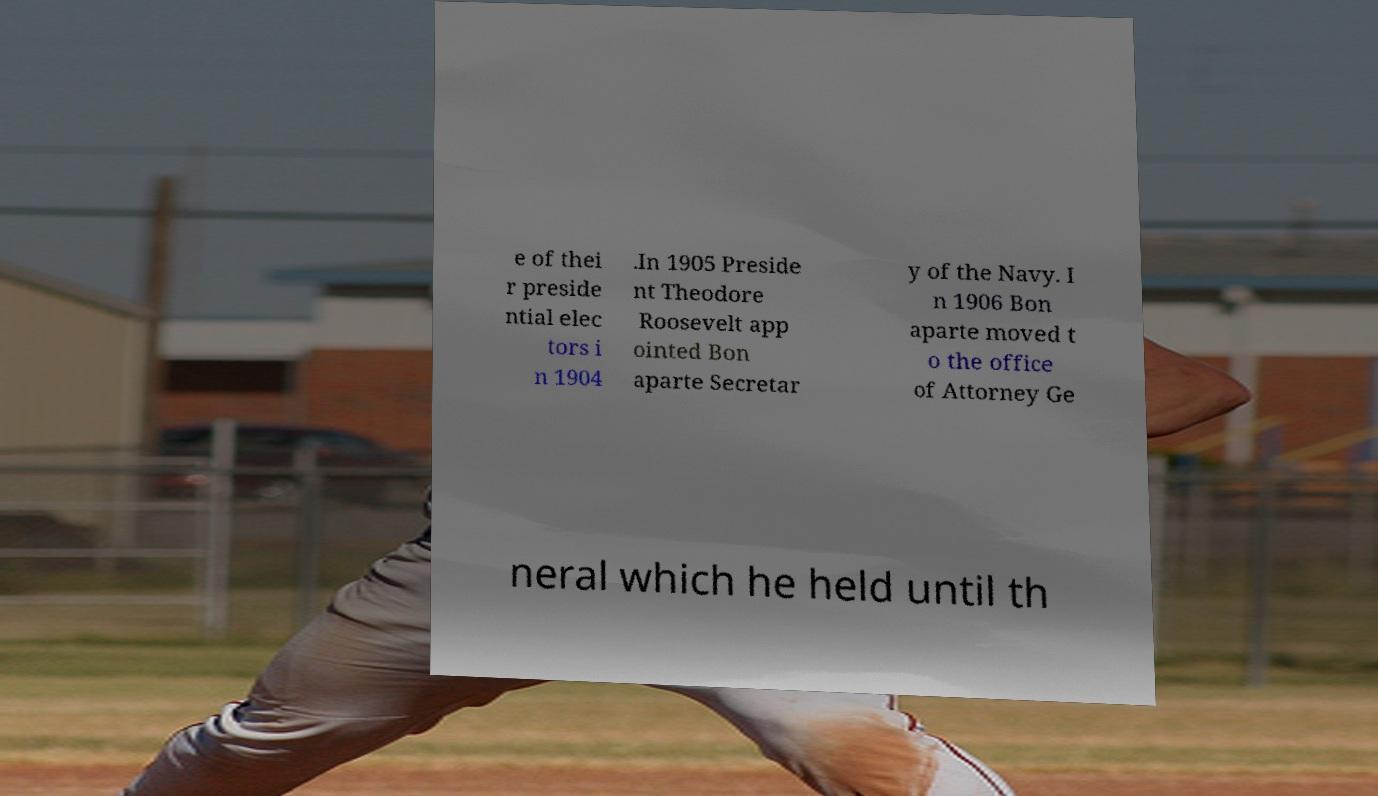For documentation purposes, I need the text within this image transcribed. Could you provide that? e of thei r preside ntial elec tors i n 1904 .In 1905 Preside nt Theodore Roosevelt app ointed Bon aparte Secretar y of the Navy. I n 1906 Bon aparte moved t o the office of Attorney Ge neral which he held until th 